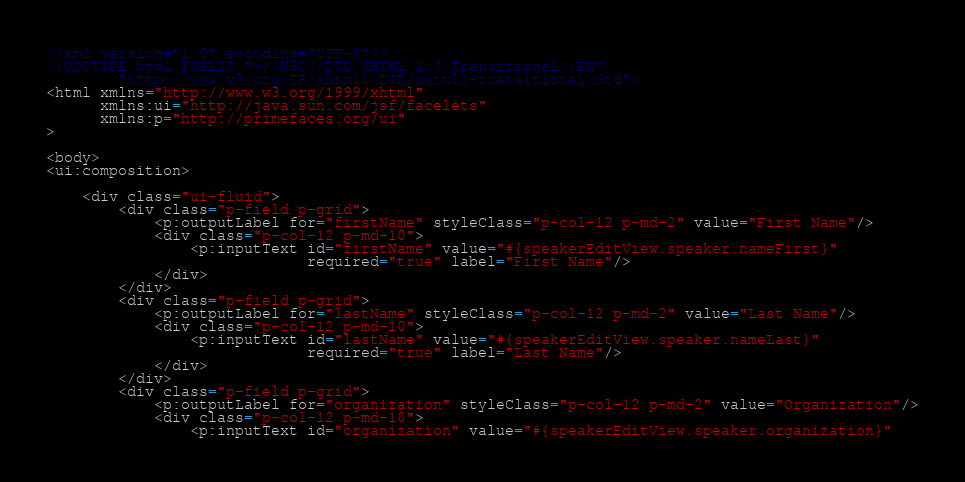Convert code to text. <code><loc_0><loc_0><loc_500><loc_500><_HTML_><?xml version="1.0" encoding="UTF-8"?>
<!DOCTYPE html PUBLIC "-//W3C//DTD XHTML 1.0 Transitional//EN"
        "http://www.w3.org/TR/xhtml1/DTD/xhtml1-transitional.dtd">
<html xmlns="http://www.w3.org/1999/xhtml"
      xmlns:ui="http://java.sun.com/jsf/facelets"
      xmlns:p="http://primefaces.org/ui"
>

<body>
<ui:composition>

    <div class="ui-fluid">
        <div class="p-field p-grid">
            <p:outputLabel for="firstName" styleClass="p-col-12 p-md-2" value="First Name"/>
            <div class="p-col-12 p-md-10">
                <p:inputText id="firstName" value="#{speakerEditView.speaker.nameFirst}"
                             required="true" label="First Name"/>
            </div>
        </div>
        <div class="p-field p-grid">
            <p:outputLabel for="lastName" styleClass="p-col-12 p-md-2" value="Last Name"/>
            <div class="p-col-12 p-md-10">
                <p:inputText id="lastName" value="#{speakerEditView.speaker.nameLast}"
                             required="true" label="Last Name"/>
            </div>
        </div>
        <div class="p-field p-grid">
            <p:outputLabel for="organization" styleClass="p-col-12 p-md-2" value="Organization"/>
            <div class="p-col-12 p-md-10">
                <p:inputText id="organization" value="#{speakerEditView.speaker.organization}"</code> 